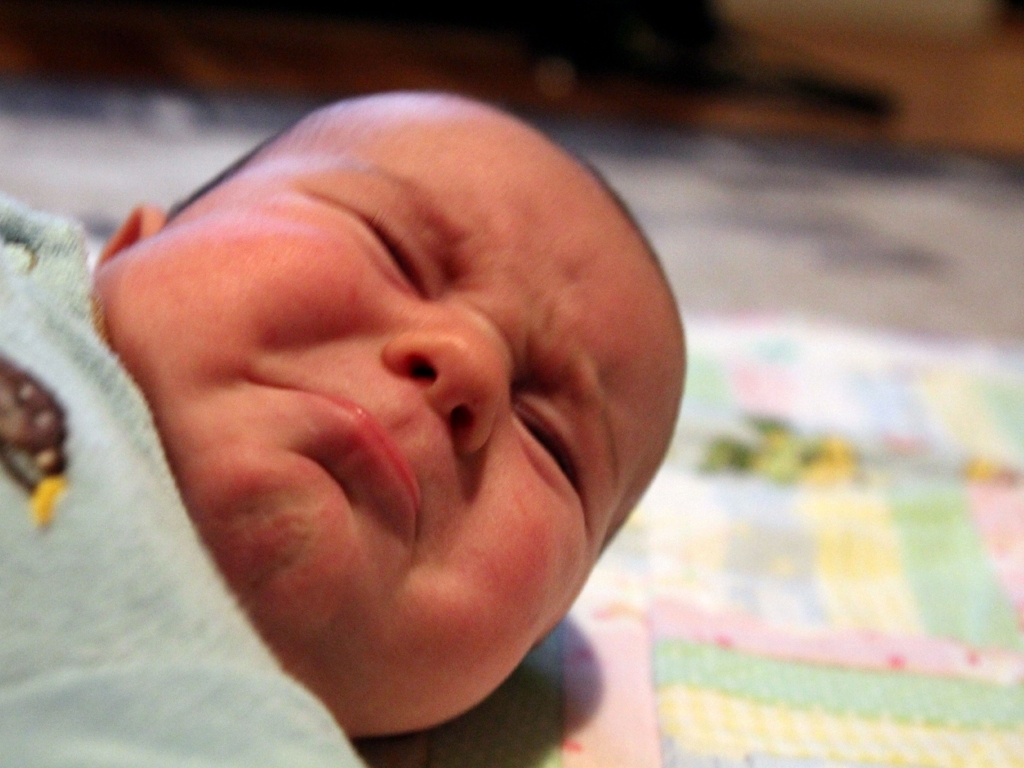Can you describe the setting where the baby is? Yes, the baby is lying on a soft surface, which appears to be a quilt or a baby blanket with various patterns. The environment seems to be indoors, likely a home setting, which is suggested by the warm lighting and the comfortable appearance of the resting place. What details can you tell about the baby's clothing? The newborn is dressed in a cozy, light blue onesie. It features a cute design, possibly a small animal or a playful motif. The onesie suggests that the baby is kept in comfortable attire suitable for rest or sleep. 